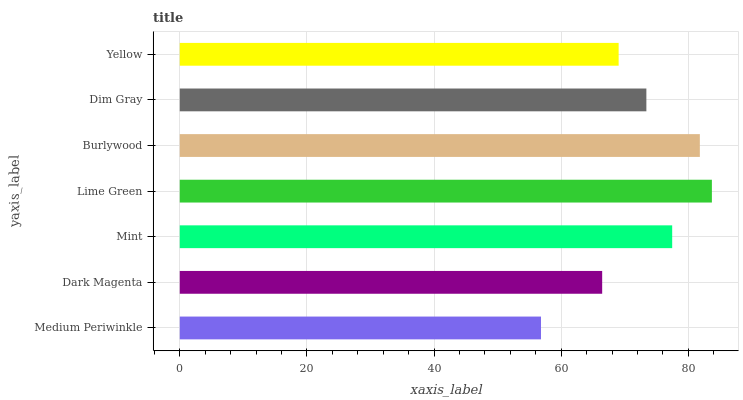Is Medium Periwinkle the minimum?
Answer yes or no. Yes. Is Lime Green the maximum?
Answer yes or no. Yes. Is Dark Magenta the minimum?
Answer yes or no. No. Is Dark Magenta the maximum?
Answer yes or no. No. Is Dark Magenta greater than Medium Periwinkle?
Answer yes or no. Yes. Is Medium Periwinkle less than Dark Magenta?
Answer yes or no. Yes. Is Medium Periwinkle greater than Dark Magenta?
Answer yes or no. No. Is Dark Magenta less than Medium Periwinkle?
Answer yes or no. No. Is Dim Gray the high median?
Answer yes or no. Yes. Is Dim Gray the low median?
Answer yes or no. Yes. Is Lime Green the high median?
Answer yes or no. No. Is Dark Magenta the low median?
Answer yes or no. No. 